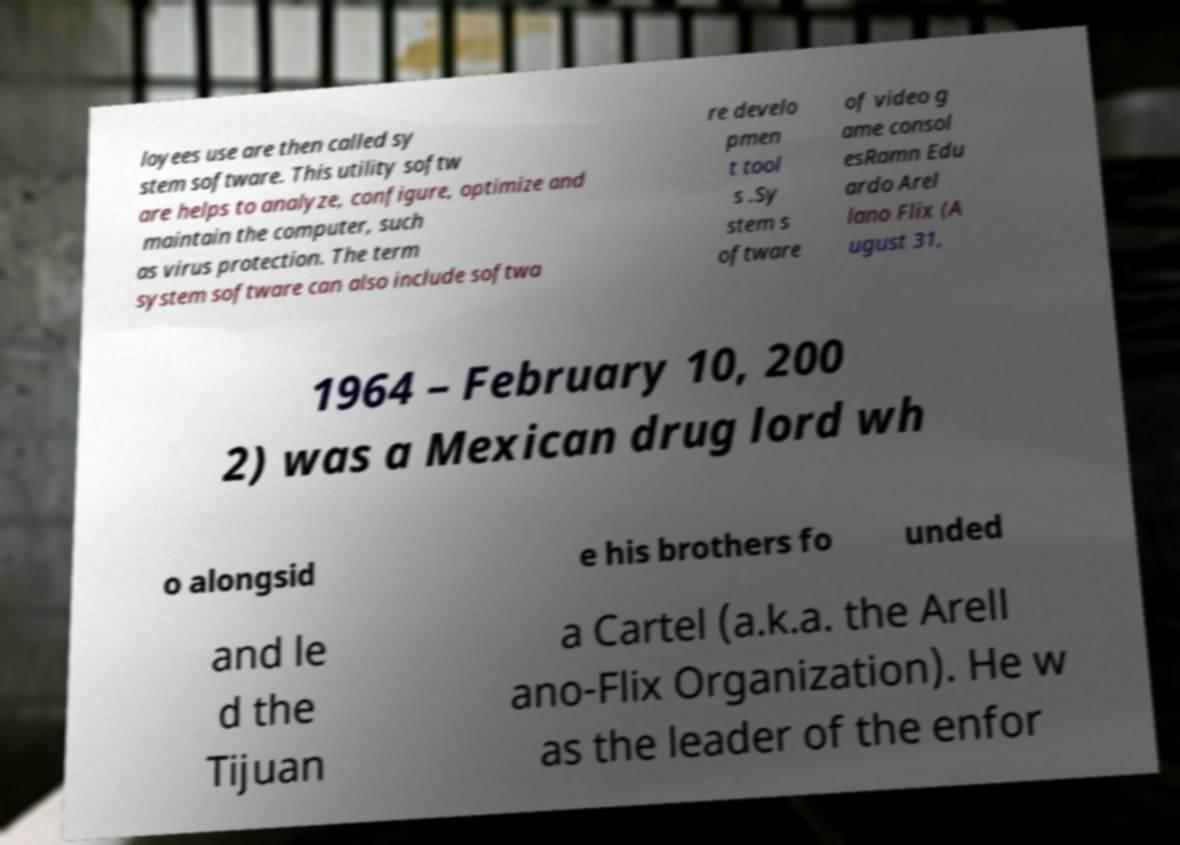Can you read and provide the text displayed in the image?This photo seems to have some interesting text. Can you extract and type it out for me? loyees use are then called sy stem software. This utility softw are helps to analyze, configure, optimize and maintain the computer, such as virus protection. The term system software can also include softwa re develo pmen t tool s .Sy stem s oftware of video g ame consol esRamn Edu ardo Arel lano Flix (A ugust 31, 1964 – February 10, 200 2) was a Mexican drug lord wh o alongsid e his brothers fo unded and le d the Tijuan a Cartel (a.k.a. the Arell ano-Flix Organization). He w as the leader of the enfor 